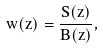Convert formula to latex. <formula><loc_0><loc_0><loc_500><loc_500>w ( z ) = \frac { S ( z ) } { B ( z ) } ,</formula> 